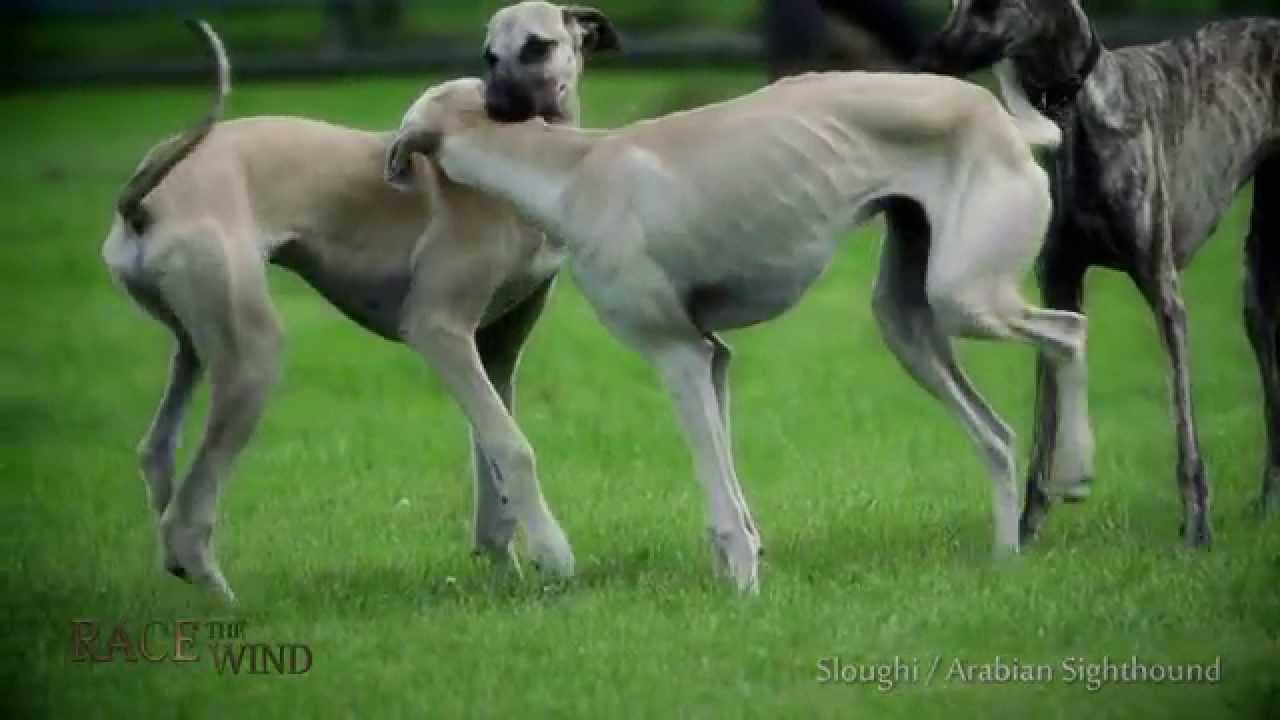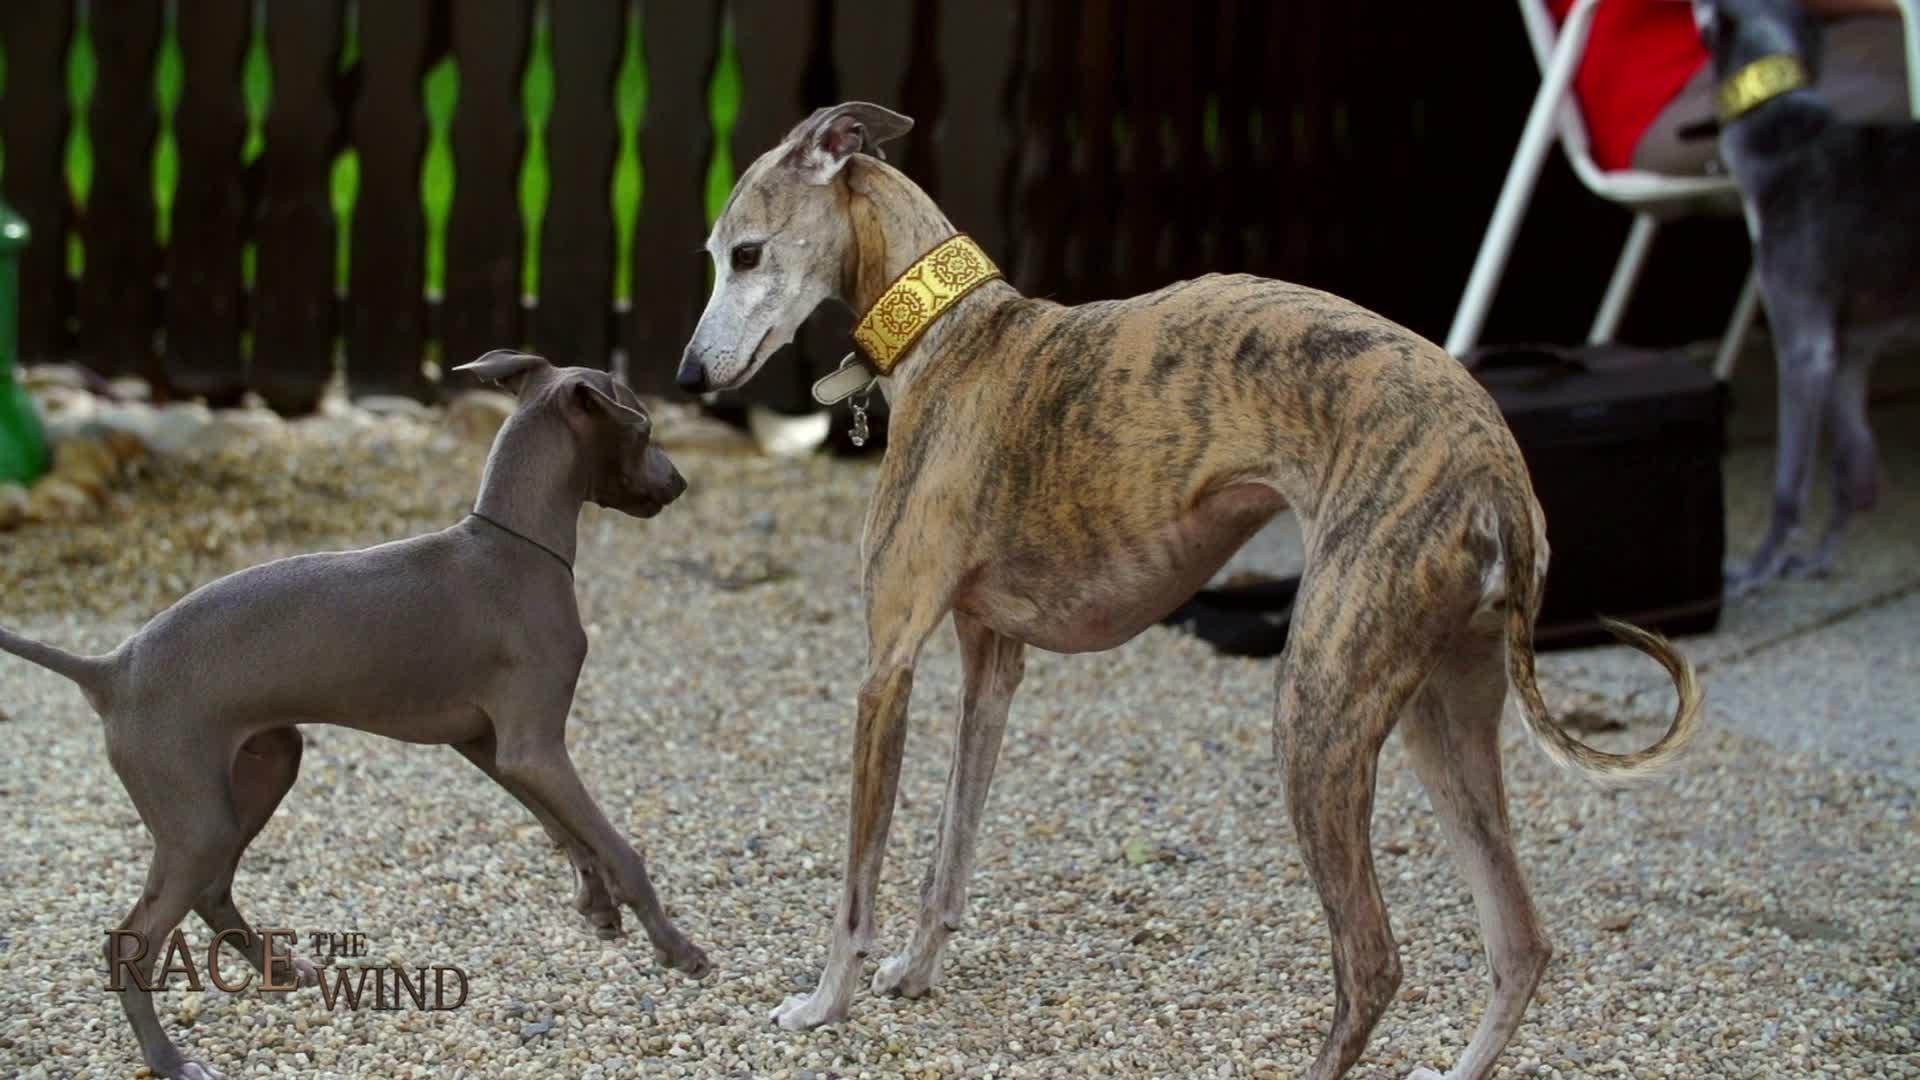The first image is the image on the left, the second image is the image on the right. Analyze the images presented: Is the assertion "An image shows one hound running in front of another and kicking up clouds of dust." valid? Answer yes or no. No. The first image is the image on the left, the second image is the image on the right. Analyze the images presented: Is the assertion "One animal is on a leash." valid? Answer yes or no. No. 